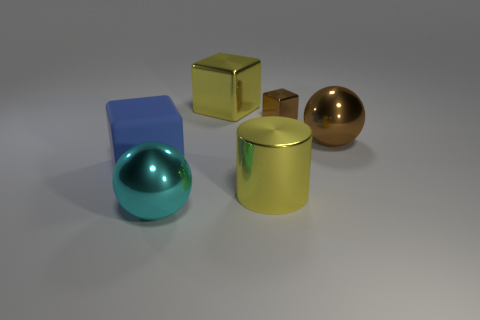Are there any other things that have the same size as the brown block?
Offer a terse response. No. What number of other objects are the same material as the cyan thing?
Offer a terse response. 4. There is a object that is the same color as the big cylinder; what shape is it?
Your response must be concise. Cube. There is a metal sphere that is behind the large blue object; what size is it?
Give a very brief answer. Large. The big brown object that is the same material as the tiny cube is what shape?
Provide a short and direct response. Sphere. Are the big blue cube and the large cylinder right of the large rubber cube made of the same material?
Your response must be concise. No. There is a large metal thing that is to the left of the yellow shiny cube; is its shape the same as the large blue thing?
Keep it short and to the point. No. What material is the large brown object that is the same shape as the cyan object?
Make the answer very short. Metal. There is a large rubber thing; is its shape the same as the yellow thing left of the big cylinder?
Make the answer very short. Yes. What is the color of the large metallic object that is both left of the yellow cylinder and to the right of the cyan metallic thing?
Your response must be concise. Yellow. 